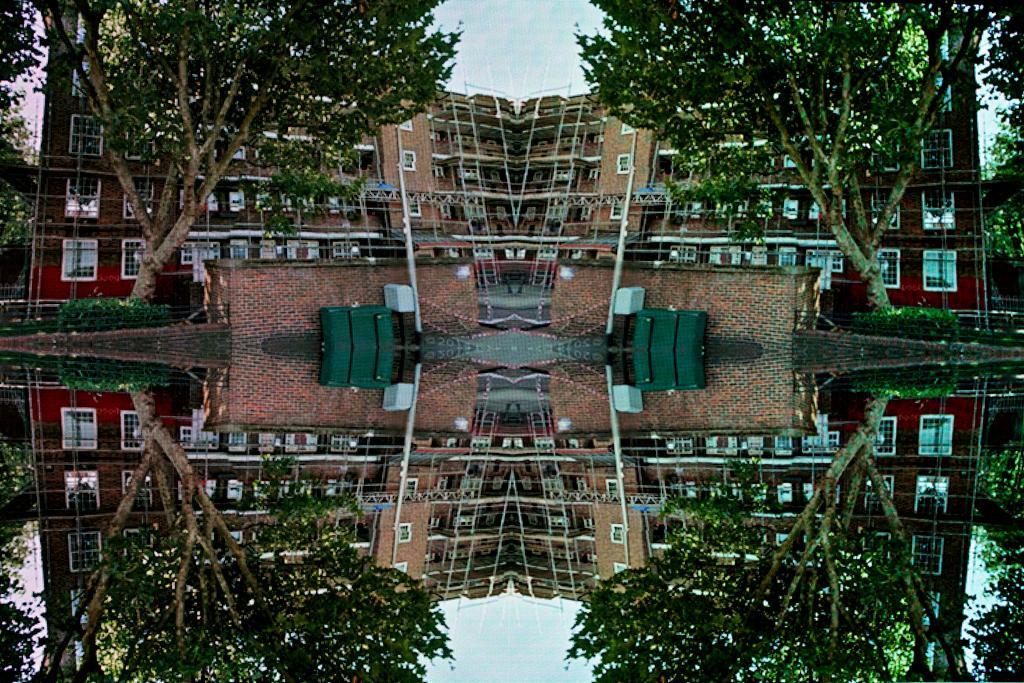How would you summarize this image in a sentence or two? In the image we can see there are trees and there are buildings. In the water there is a reflection of trees and buildings. 